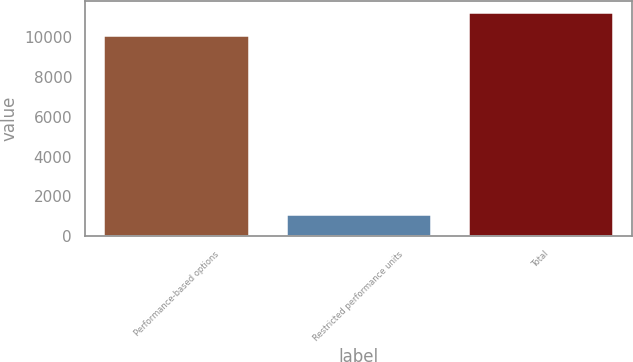Convert chart to OTSL. <chart><loc_0><loc_0><loc_500><loc_500><bar_chart><fcel>Performance-based options<fcel>Restricted performance units<fcel>Total<nl><fcel>10112<fcel>1140<fcel>11252<nl></chart> 